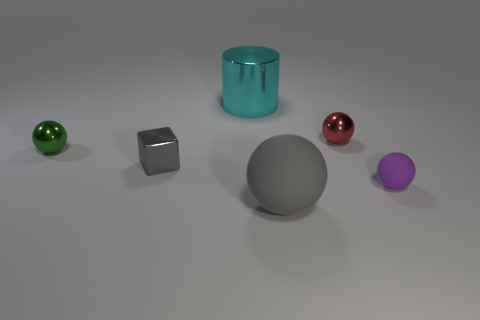There is a matte object left of the tiny purple rubber object; is it the same size as the matte object behind the large gray rubber ball?
Offer a very short reply. No. What number of metal objects are both in front of the cyan metallic cylinder and on the left side of the large gray matte sphere?
Give a very brief answer. 2. There is another matte object that is the same shape as the big gray matte thing; what color is it?
Offer a very short reply. Purple. Is the number of big cyan cylinders less than the number of large green cylinders?
Ensure brevity in your answer.  No. Is the size of the gray metal block the same as the gray object right of the cyan thing?
Give a very brief answer. No. There is a rubber object that is on the left side of the small thing that is right of the red thing; what color is it?
Provide a succinct answer. Gray. How many objects are either tiny balls on the right side of the small red sphere or metallic things to the left of the tiny red metallic ball?
Provide a succinct answer. 4. Do the gray rubber thing and the green shiny object have the same size?
Provide a succinct answer. No. Does the big thing that is in front of the gray shiny block have the same shape as the metal thing right of the big metal cylinder?
Your answer should be compact. Yes. The gray block has what size?
Offer a terse response. Small. 